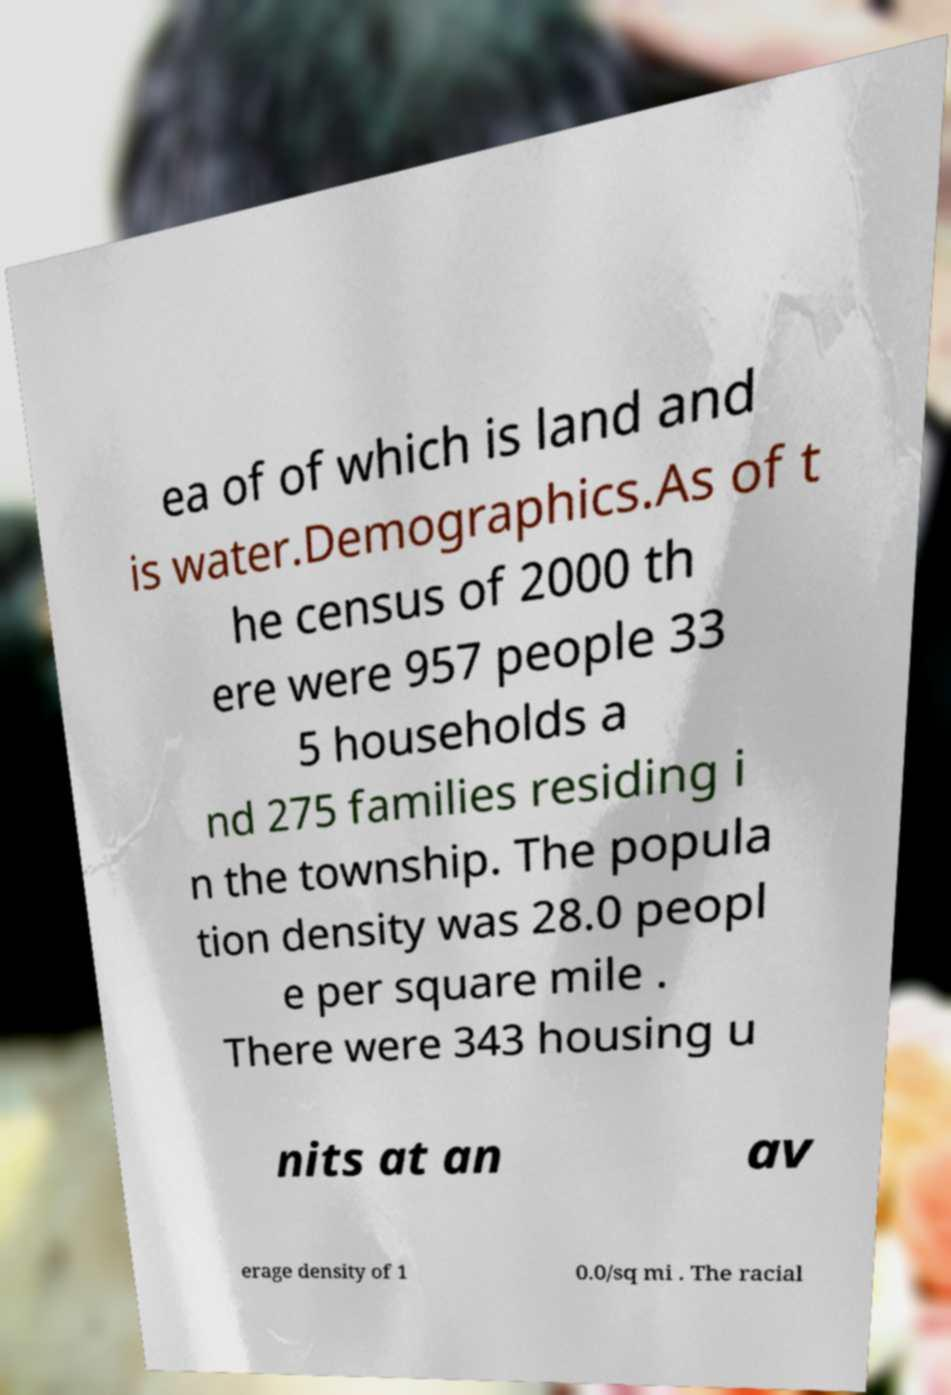Please identify and transcribe the text found in this image. ea of of which is land and is water.Demographics.As of t he census of 2000 th ere were 957 people 33 5 households a nd 275 families residing i n the township. The popula tion density was 28.0 peopl e per square mile . There were 343 housing u nits at an av erage density of 1 0.0/sq mi . The racial 